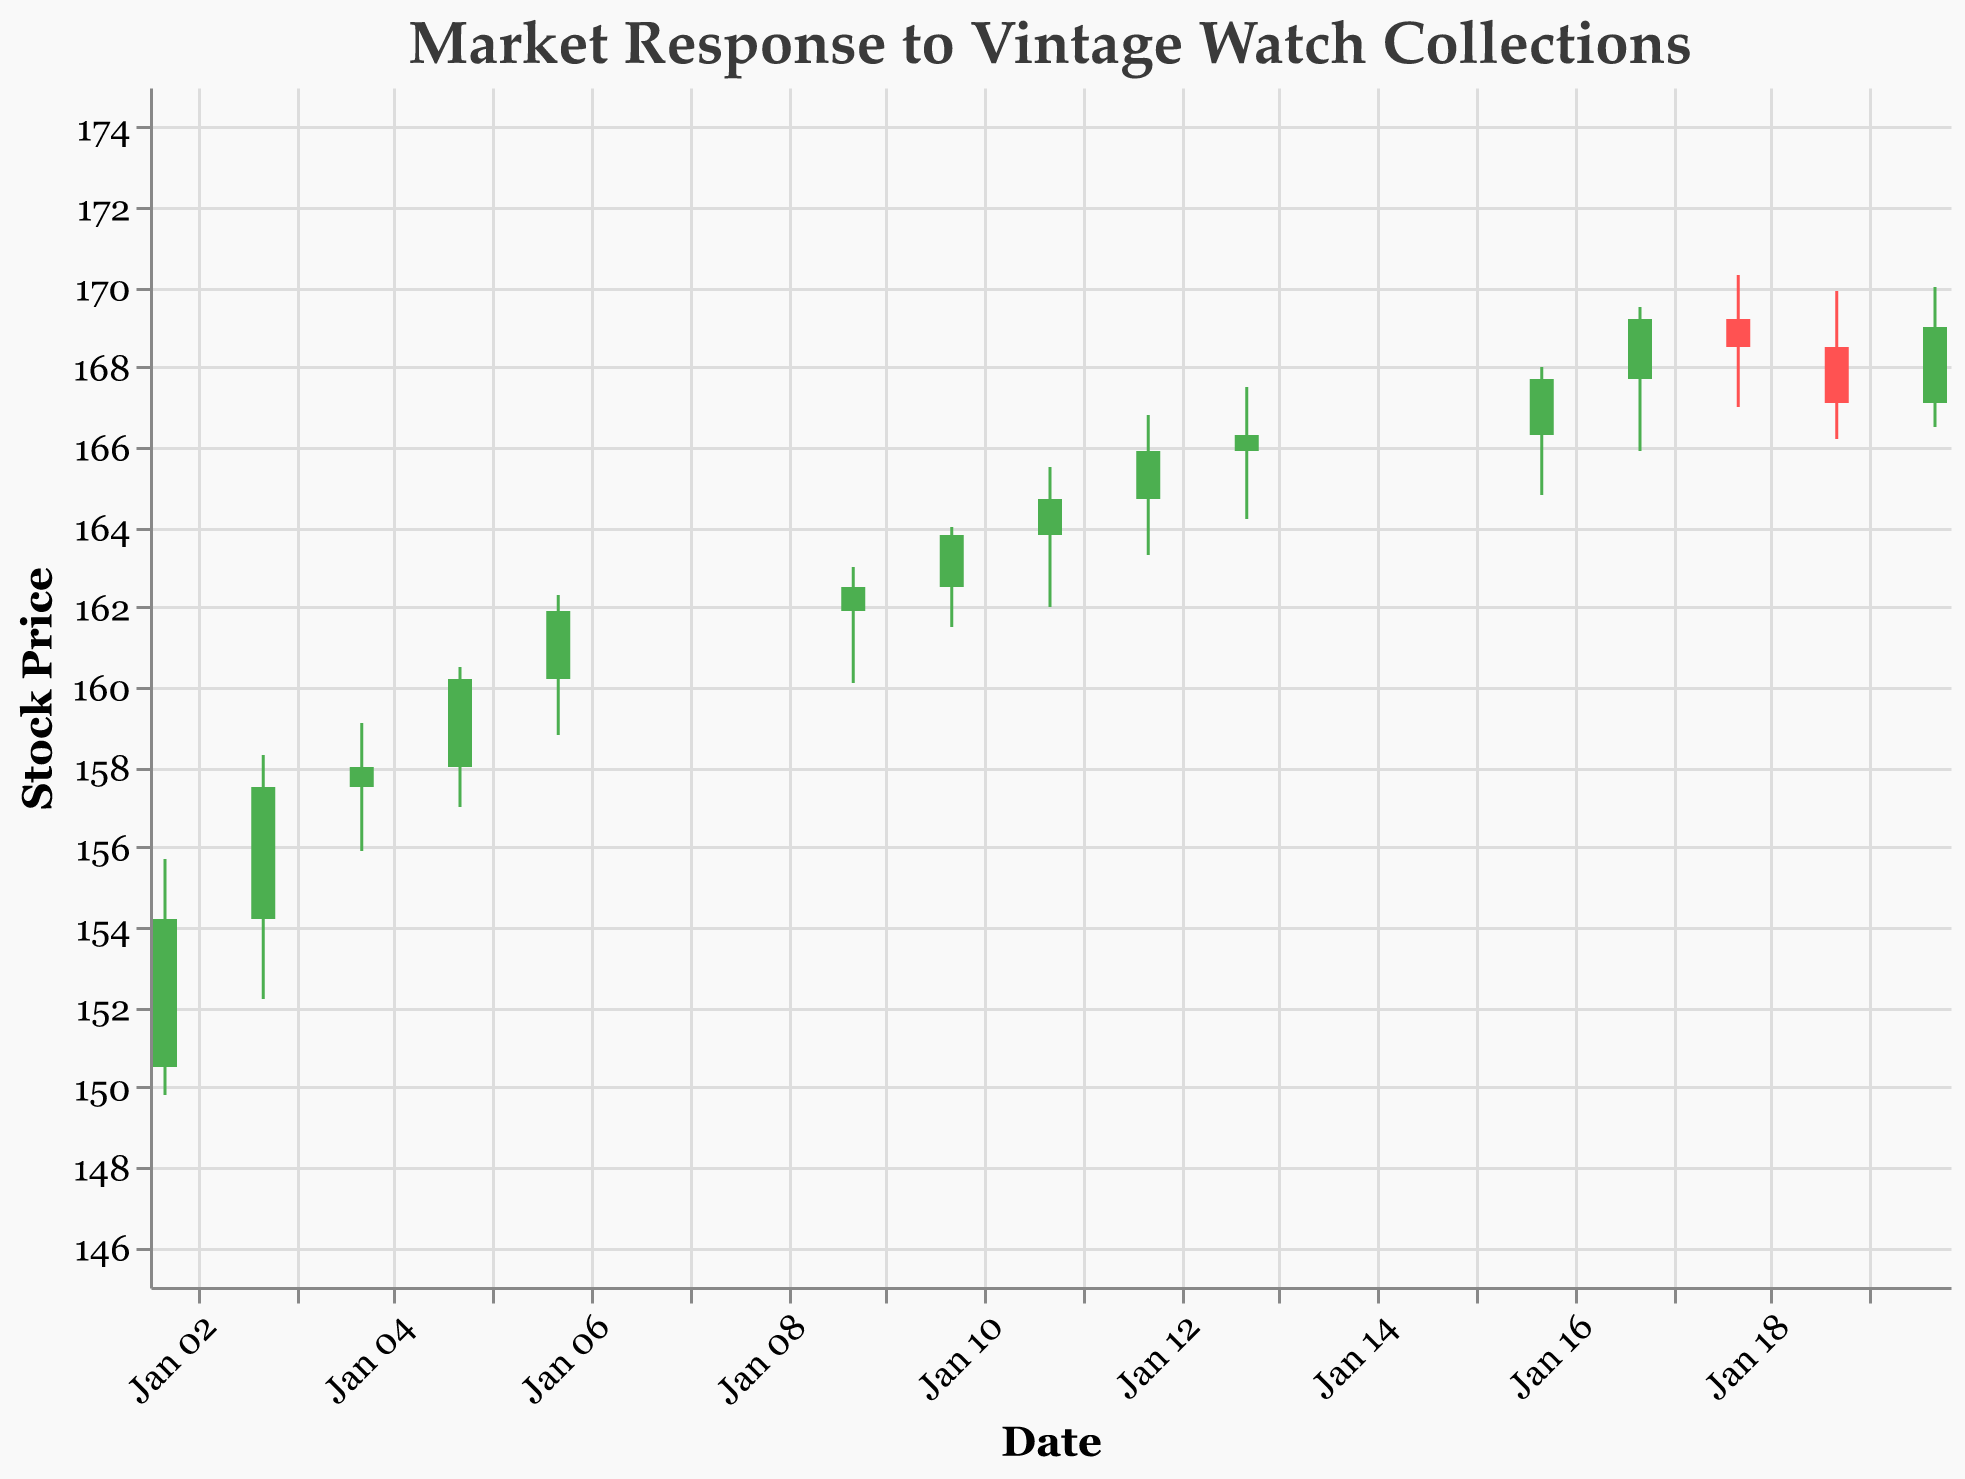What's the title of the figure? The title is usually located at the top of the plot and describes the main subject of the figure. Here, the title reads "Market Response to Vintage Watch Collections."
Answer: Market Response to Vintage Watch Collections Which day has the highest stock price (High)? Look for the highest value in the 'High' column. The highest value is 170.3, which occurred on January 18, 2023.
Answer: January 18, 2023 What is the color of the bars when the stock closes higher than it opened? According to the encoding rules, the bars are green when the stock closes higher than it opened.
Answer: Green What is the difference between the closing prices on January 2 and January 20? The closing price on January 2 is 154.2, and the closing price on January 20 is 169. Calculate the difference: 169 - 154.2 = 14.8.
Answer: 14.8 Which date had the highest trading volume? Look for the highest value in the 'Volume' column. The highest volume is 162,000, which occurred on January 18, 2023.
Answer: January 18, 2023 What was the opening stock price on January 13? Check the 'Open' column for January 13. The opening price is 165.9.
Answer: 165.9 How many days did the stock close lower than it opened? Identify the days where the closing price is less than the opening price by inspecting each row: January 18 and January 19. Thus, there are 2 days.
Answer: 2 Comparing January 5 and January 10, on which day was the stock price higher at closing? The closing price on January 5 is 160.2, and on January 10 is 163.8. Comparing the two, January 10 had a higher closing price.
Answer: January 10 What is the range of stock prices on January 6? To find the range, subtract the lowest price from the highest price on January 6: 162.3 - 158.8 = 3.5.
Answer: 3.5 On which date did the stock price close above 165 for the first time? Scan the 'Close' column for the first occurrence of a value above 165. The stock first closed above 165 on January 12, 2023.
Answer: January 12, 2023 